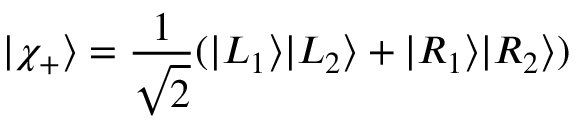Convert formula to latex. <formula><loc_0><loc_0><loc_500><loc_500>| \chi _ { + } \rangle = \frac { 1 } { \sqrt { 2 } } ( | L _ { 1 } \rangle | L _ { 2 } \rangle + | R _ { 1 } \rangle | R _ { 2 } \rangle )</formula> 